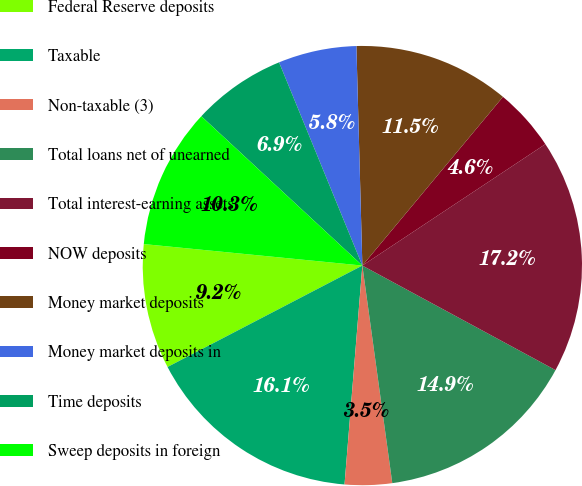<chart> <loc_0><loc_0><loc_500><loc_500><pie_chart><fcel>Federal Reserve deposits<fcel>Taxable<fcel>Non-taxable (3)<fcel>Total loans net of unearned<fcel>Total interest-earning assets<fcel>NOW deposits<fcel>Money market deposits<fcel>Money market deposits in<fcel>Time deposits<fcel>Sweep deposits in foreign<nl><fcel>9.2%<fcel>16.07%<fcel>3.47%<fcel>14.93%<fcel>17.22%<fcel>4.62%<fcel>11.49%<fcel>5.76%<fcel>6.91%<fcel>10.34%<nl></chart> 